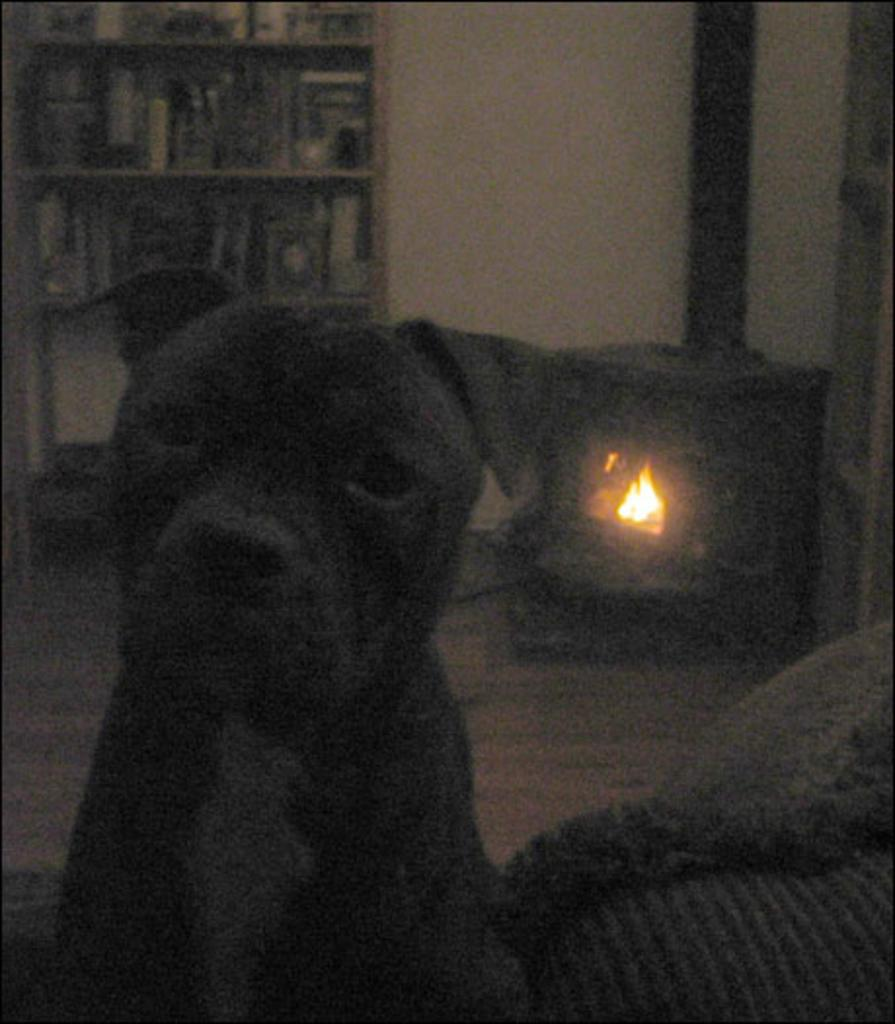What type of animal is present in the image? There is a dog in the image. What color is the dog? The dog is black in color. What can be seen in the background of the image? There is a fireplace in the image. Where are the books located in the image? The books are in a bookshelf in the image. What type of bells can be heard ringing in the image? There are no bells present in the image, and therefore no sound can be heard. What type of work is the dog performing in the image? The dog is not performing any work in the image; it is simply present as an animal. 